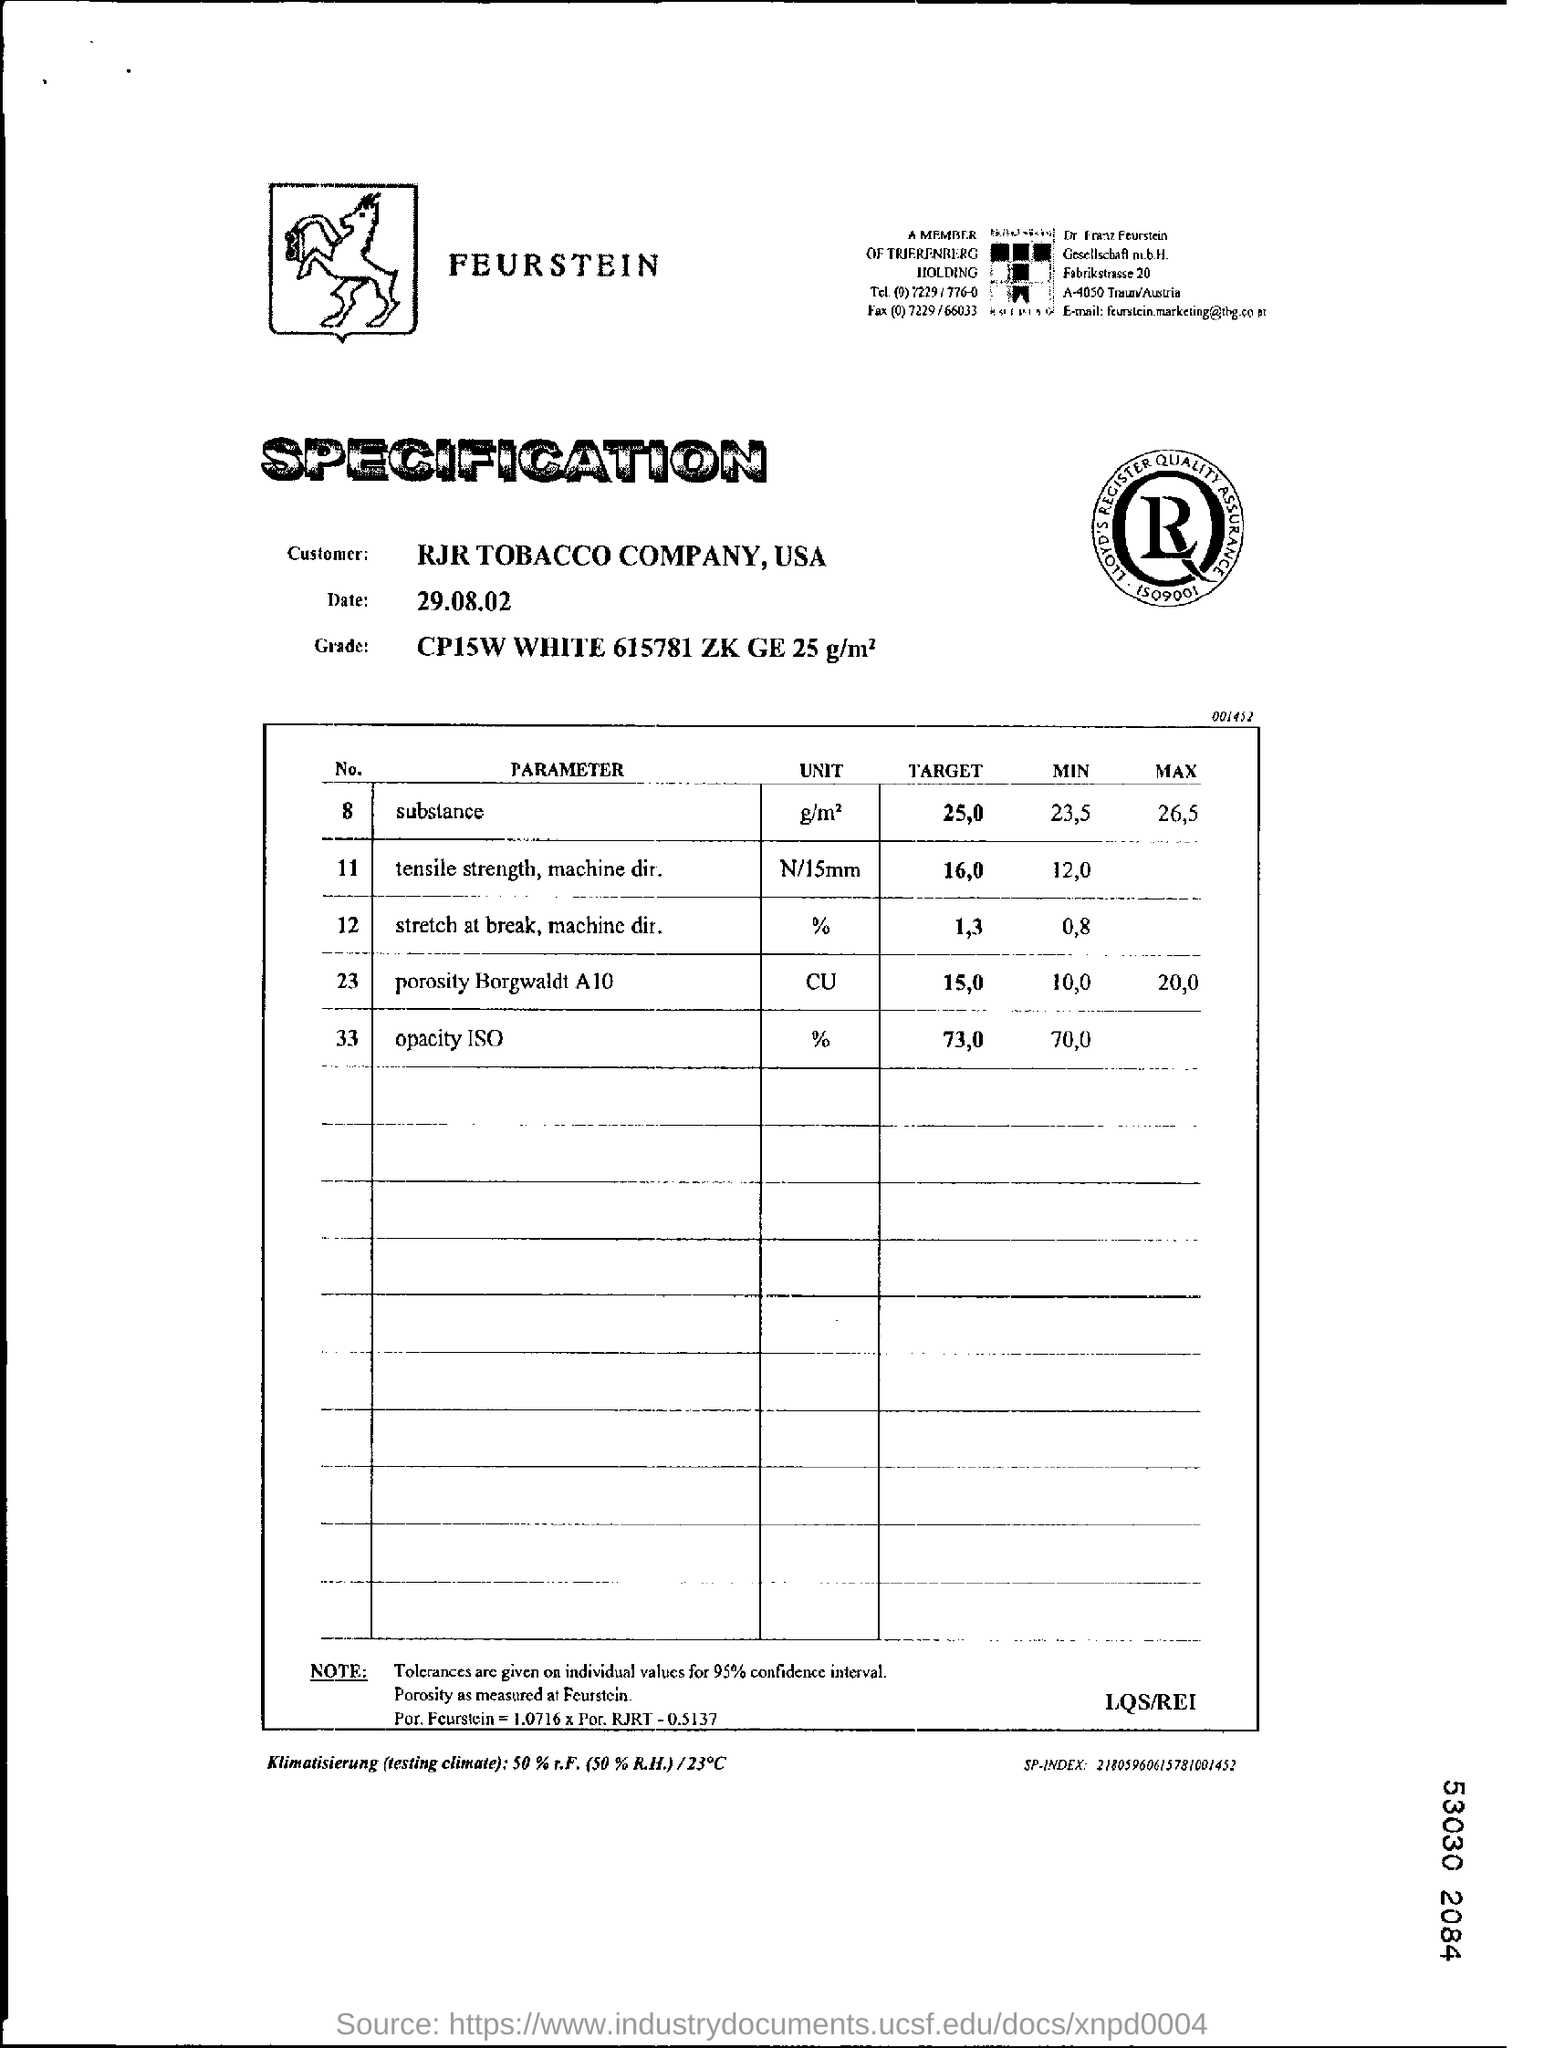What is the name of customer?
Your answer should be very brief. RJR TOBACCO COMPANY. 